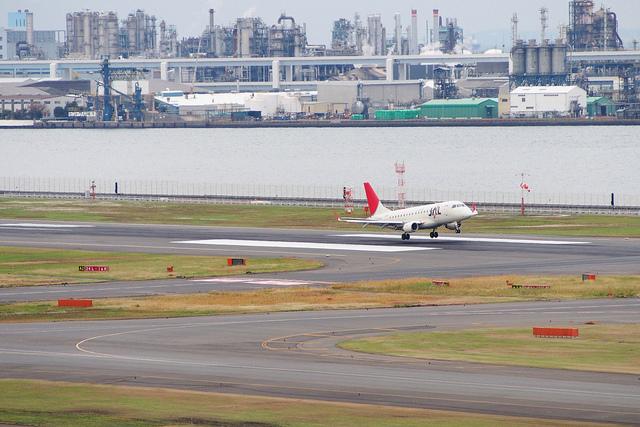Is the airplane landing?
Concise answer only. No. How big is the airplane?
Write a very short answer. Medium. What is this aircraft on the runway?
Concise answer only. Plane. 